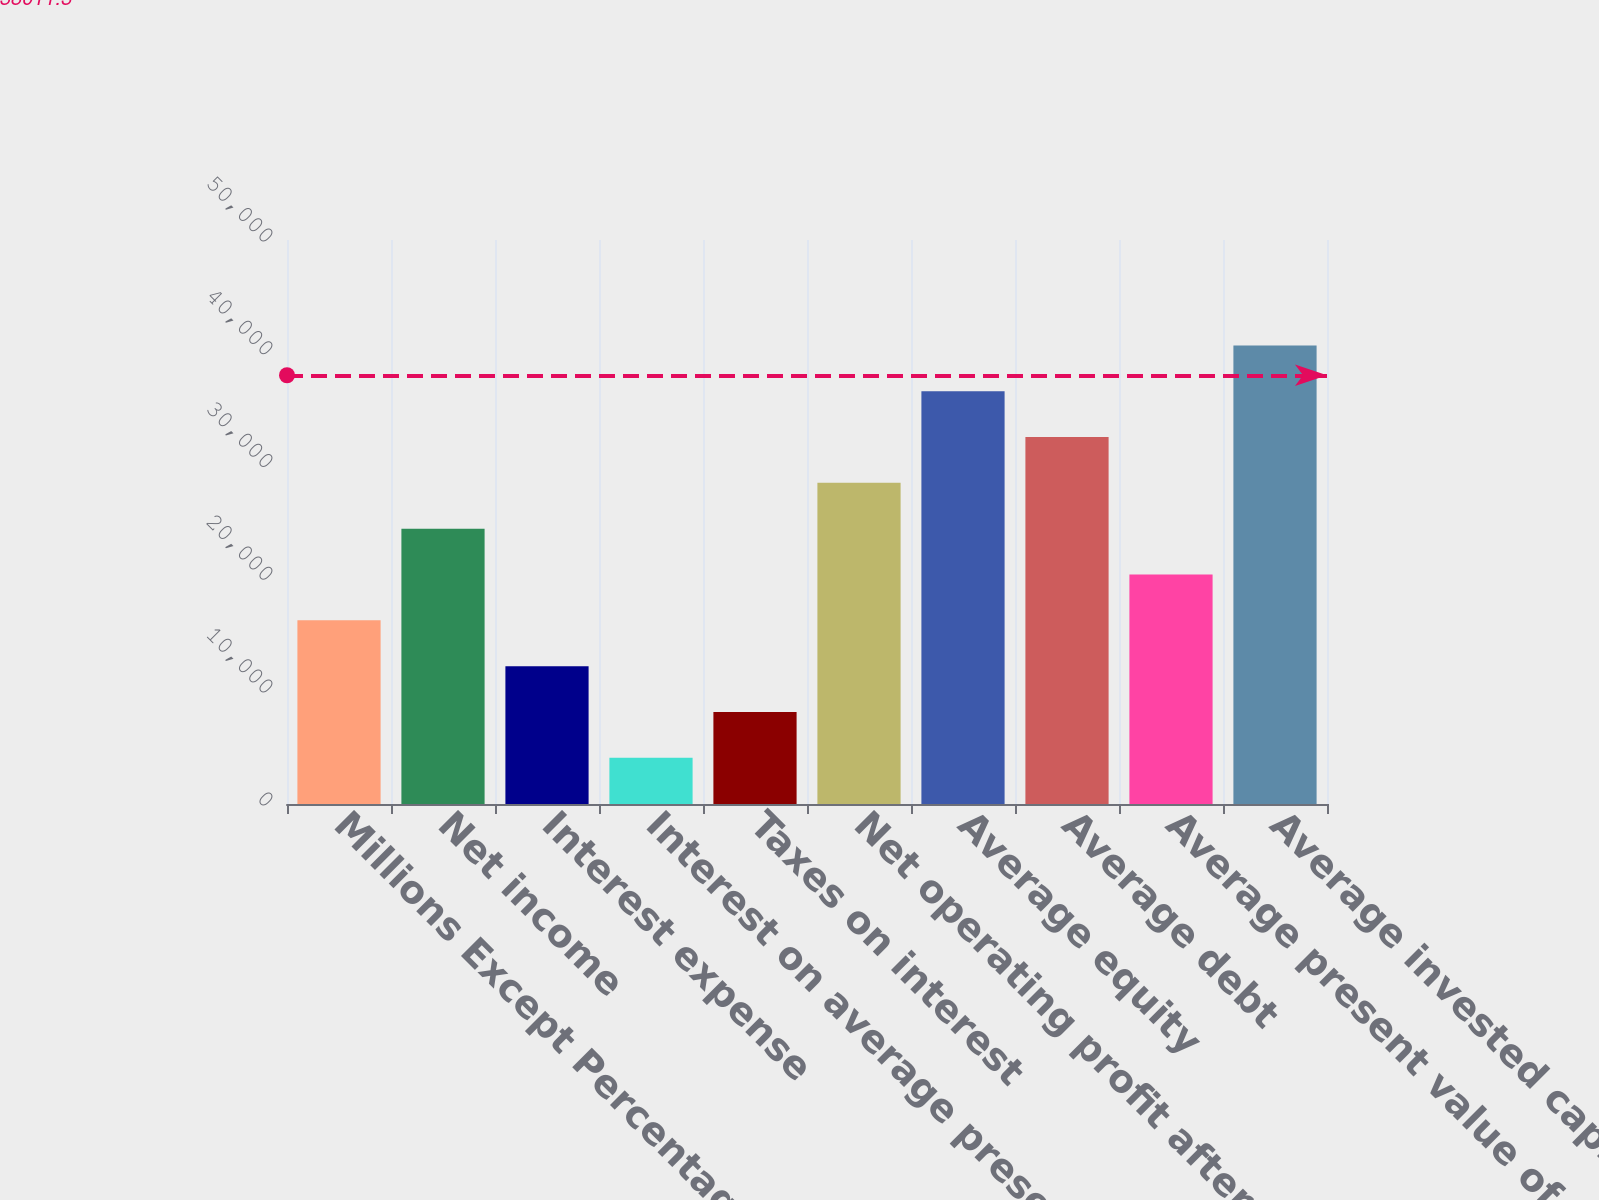Convert chart. <chart><loc_0><loc_0><loc_500><loc_500><bar_chart><fcel>Millions Except Percentages<fcel>Net income<fcel>Interest expense<fcel>Interest on average present<fcel>Taxes on interest<fcel>Net operating profit after<fcel>Average equity<fcel>Average debt<fcel>Average present value of<fcel>Average invested capital as<nl><fcel>16279.8<fcel>24405.8<fcel>12216.7<fcel>4090.64<fcel>8153.68<fcel>28468.9<fcel>36595<fcel>32531.9<fcel>20342.8<fcel>40658<nl></chart> 